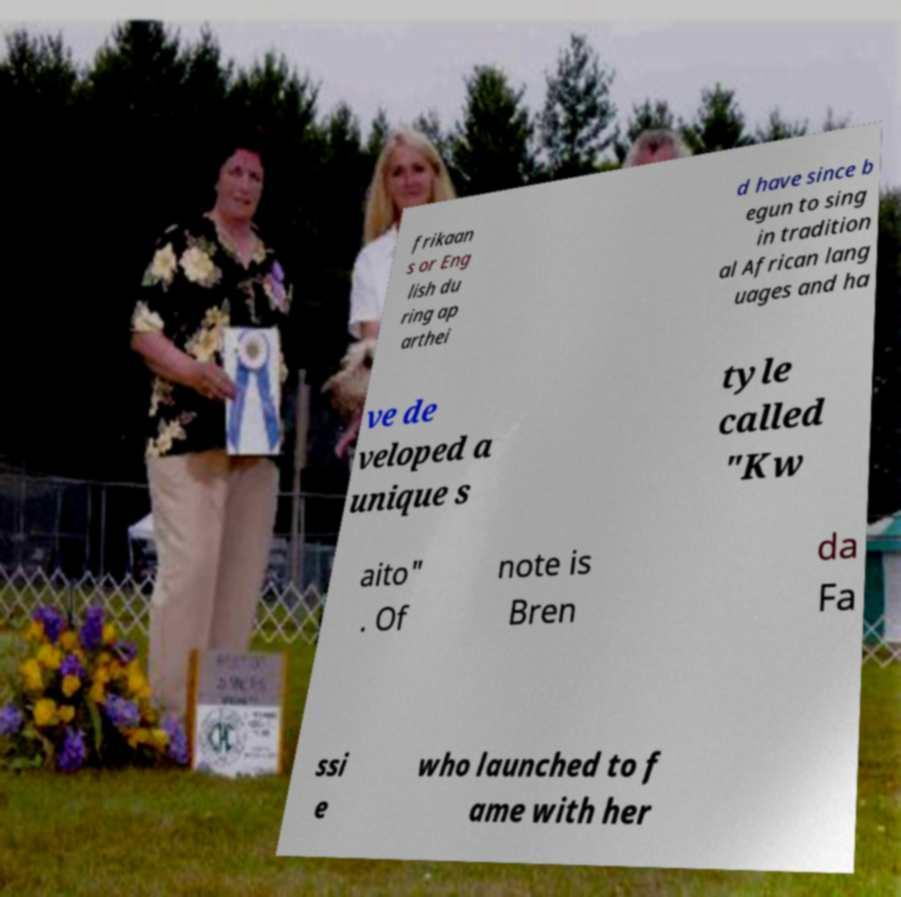For documentation purposes, I need the text within this image transcribed. Could you provide that? frikaan s or Eng lish du ring ap arthei d have since b egun to sing in tradition al African lang uages and ha ve de veloped a unique s tyle called "Kw aito" . Of note is Bren da Fa ssi e who launched to f ame with her 